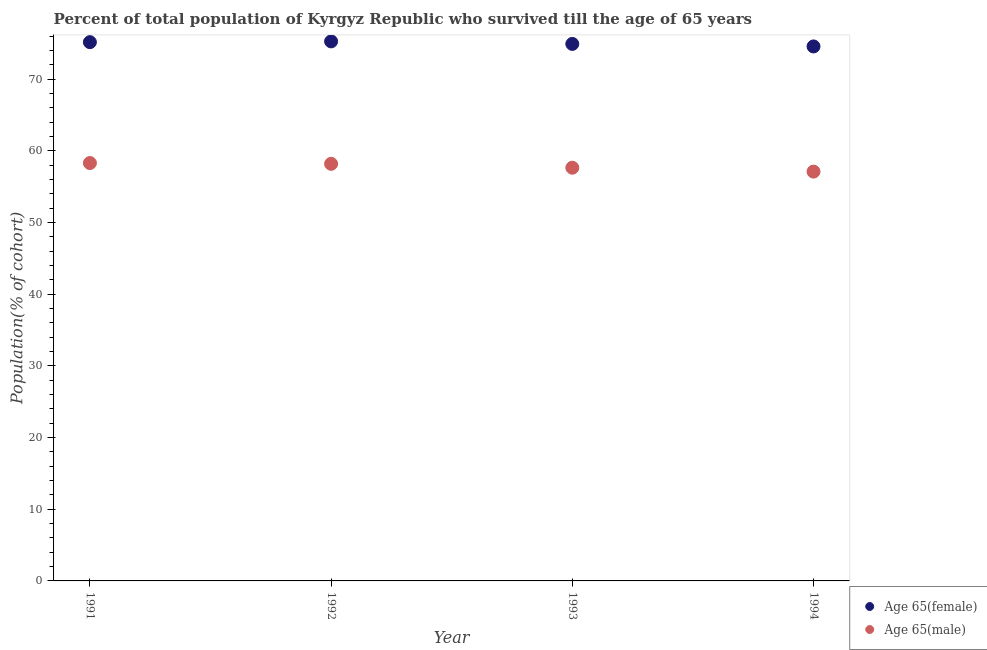What is the percentage of female population who survived till age of 65 in 1993?
Ensure brevity in your answer.  74.93. Across all years, what is the maximum percentage of female population who survived till age of 65?
Ensure brevity in your answer.  75.28. Across all years, what is the minimum percentage of male population who survived till age of 65?
Keep it short and to the point. 57.11. In which year was the percentage of male population who survived till age of 65 minimum?
Keep it short and to the point. 1994. What is the total percentage of male population who survived till age of 65 in the graph?
Keep it short and to the point. 231.28. What is the difference between the percentage of male population who survived till age of 65 in 1992 and that in 1994?
Provide a succinct answer. 1.08. What is the difference between the percentage of female population who survived till age of 65 in 1991 and the percentage of male population who survived till age of 65 in 1992?
Provide a succinct answer. 16.98. What is the average percentage of female population who survived till age of 65 per year?
Make the answer very short. 74.99. In the year 1992, what is the difference between the percentage of male population who survived till age of 65 and percentage of female population who survived till age of 65?
Give a very brief answer. -17.08. What is the ratio of the percentage of female population who survived till age of 65 in 1993 to that in 1994?
Provide a short and direct response. 1. What is the difference between the highest and the second highest percentage of male population who survived till age of 65?
Offer a very short reply. 0.11. What is the difference between the highest and the lowest percentage of female population who survived till age of 65?
Ensure brevity in your answer.  0.7. In how many years, is the percentage of female population who survived till age of 65 greater than the average percentage of female population who survived till age of 65 taken over all years?
Give a very brief answer. 2. Is the sum of the percentage of male population who survived till age of 65 in 1992 and 1993 greater than the maximum percentage of female population who survived till age of 65 across all years?
Your answer should be very brief. Yes. Is the percentage of male population who survived till age of 65 strictly greater than the percentage of female population who survived till age of 65 over the years?
Ensure brevity in your answer.  No. How many dotlines are there?
Provide a short and direct response. 2. Does the graph contain any zero values?
Provide a succinct answer. No. Where does the legend appear in the graph?
Your answer should be compact. Bottom right. What is the title of the graph?
Give a very brief answer. Percent of total population of Kyrgyz Republic who survived till the age of 65 years. What is the label or title of the X-axis?
Offer a very short reply. Year. What is the label or title of the Y-axis?
Your response must be concise. Population(% of cohort). What is the Population(% of cohort) in Age 65(female) in 1991?
Provide a short and direct response. 75.18. What is the Population(% of cohort) in Age 65(male) in 1991?
Offer a very short reply. 58.31. What is the Population(% of cohort) of Age 65(female) in 1992?
Offer a very short reply. 75.28. What is the Population(% of cohort) of Age 65(male) in 1992?
Your answer should be very brief. 58.2. What is the Population(% of cohort) of Age 65(female) in 1993?
Give a very brief answer. 74.93. What is the Population(% of cohort) in Age 65(male) in 1993?
Your answer should be compact. 57.66. What is the Population(% of cohort) of Age 65(female) in 1994?
Offer a terse response. 74.58. What is the Population(% of cohort) of Age 65(male) in 1994?
Make the answer very short. 57.11. Across all years, what is the maximum Population(% of cohort) in Age 65(female)?
Give a very brief answer. 75.28. Across all years, what is the maximum Population(% of cohort) of Age 65(male)?
Provide a succinct answer. 58.31. Across all years, what is the minimum Population(% of cohort) in Age 65(female)?
Your answer should be very brief. 74.58. Across all years, what is the minimum Population(% of cohort) of Age 65(male)?
Offer a very short reply. 57.11. What is the total Population(% of cohort) of Age 65(female) in the graph?
Give a very brief answer. 299.97. What is the total Population(% of cohort) of Age 65(male) in the graph?
Your answer should be compact. 231.28. What is the difference between the Population(% of cohort) of Age 65(female) in 1991 and that in 1992?
Your response must be concise. -0.11. What is the difference between the Population(% of cohort) of Age 65(male) in 1991 and that in 1992?
Make the answer very short. 0.11. What is the difference between the Population(% of cohort) of Age 65(female) in 1991 and that in 1993?
Make the answer very short. 0.24. What is the difference between the Population(% of cohort) of Age 65(male) in 1991 and that in 1993?
Your answer should be very brief. 0.65. What is the difference between the Population(% of cohort) in Age 65(female) in 1991 and that in 1994?
Your answer should be very brief. 0.6. What is the difference between the Population(% of cohort) of Age 65(male) in 1991 and that in 1994?
Provide a short and direct response. 1.2. What is the difference between the Population(% of cohort) of Age 65(female) in 1992 and that in 1993?
Give a very brief answer. 0.35. What is the difference between the Population(% of cohort) in Age 65(male) in 1992 and that in 1993?
Provide a short and direct response. 0.54. What is the difference between the Population(% of cohort) of Age 65(female) in 1992 and that in 1994?
Ensure brevity in your answer.  0.7. What is the difference between the Population(% of cohort) in Age 65(male) in 1992 and that in 1994?
Your response must be concise. 1.08. What is the difference between the Population(% of cohort) of Age 65(female) in 1993 and that in 1994?
Give a very brief answer. 0.35. What is the difference between the Population(% of cohort) of Age 65(male) in 1993 and that in 1994?
Offer a terse response. 0.54. What is the difference between the Population(% of cohort) in Age 65(female) in 1991 and the Population(% of cohort) in Age 65(male) in 1992?
Offer a terse response. 16.98. What is the difference between the Population(% of cohort) in Age 65(female) in 1991 and the Population(% of cohort) in Age 65(male) in 1993?
Provide a short and direct response. 17.52. What is the difference between the Population(% of cohort) in Age 65(female) in 1991 and the Population(% of cohort) in Age 65(male) in 1994?
Your answer should be very brief. 18.06. What is the difference between the Population(% of cohort) of Age 65(female) in 1992 and the Population(% of cohort) of Age 65(male) in 1993?
Offer a terse response. 17.63. What is the difference between the Population(% of cohort) of Age 65(female) in 1992 and the Population(% of cohort) of Age 65(male) in 1994?
Your answer should be compact. 18.17. What is the difference between the Population(% of cohort) in Age 65(female) in 1993 and the Population(% of cohort) in Age 65(male) in 1994?
Offer a terse response. 17.82. What is the average Population(% of cohort) in Age 65(female) per year?
Make the answer very short. 74.99. What is the average Population(% of cohort) in Age 65(male) per year?
Make the answer very short. 57.82. In the year 1991, what is the difference between the Population(% of cohort) in Age 65(female) and Population(% of cohort) in Age 65(male)?
Give a very brief answer. 16.87. In the year 1992, what is the difference between the Population(% of cohort) in Age 65(female) and Population(% of cohort) in Age 65(male)?
Provide a succinct answer. 17.08. In the year 1993, what is the difference between the Population(% of cohort) of Age 65(female) and Population(% of cohort) of Age 65(male)?
Keep it short and to the point. 17.27. In the year 1994, what is the difference between the Population(% of cohort) of Age 65(female) and Population(% of cohort) of Age 65(male)?
Keep it short and to the point. 17.46. What is the ratio of the Population(% of cohort) in Age 65(female) in 1991 to that in 1992?
Make the answer very short. 1. What is the ratio of the Population(% of cohort) in Age 65(male) in 1991 to that in 1993?
Offer a terse response. 1.01. What is the ratio of the Population(% of cohort) of Age 65(female) in 1991 to that in 1994?
Offer a very short reply. 1.01. What is the ratio of the Population(% of cohort) in Age 65(male) in 1991 to that in 1994?
Your answer should be compact. 1.02. What is the ratio of the Population(% of cohort) of Age 65(male) in 1992 to that in 1993?
Provide a succinct answer. 1.01. What is the ratio of the Population(% of cohort) of Age 65(female) in 1992 to that in 1994?
Your answer should be very brief. 1.01. What is the ratio of the Population(% of cohort) of Age 65(female) in 1993 to that in 1994?
Provide a succinct answer. 1. What is the ratio of the Population(% of cohort) in Age 65(male) in 1993 to that in 1994?
Your answer should be very brief. 1.01. What is the difference between the highest and the second highest Population(% of cohort) of Age 65(female)?
Ensure brevity in your answer.  0.11. What is the difference between the highest and the second highest Population(% of cohort) in Age 65(male)?
Give a very brief answer. 0.11. What is the difference between the highest and the lowest Population(% of cohort) of Age 65(female)?
Give a very brief answer. 0.7. What is the difference between the highest and the lowest Population(% of cohort) of Age 65(male)?
Ensure brevity in your answer.  1.2. 